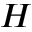Convert formula to latex. <formula><loc_0><loc_0><loc_500><loc_500>H</formula> 